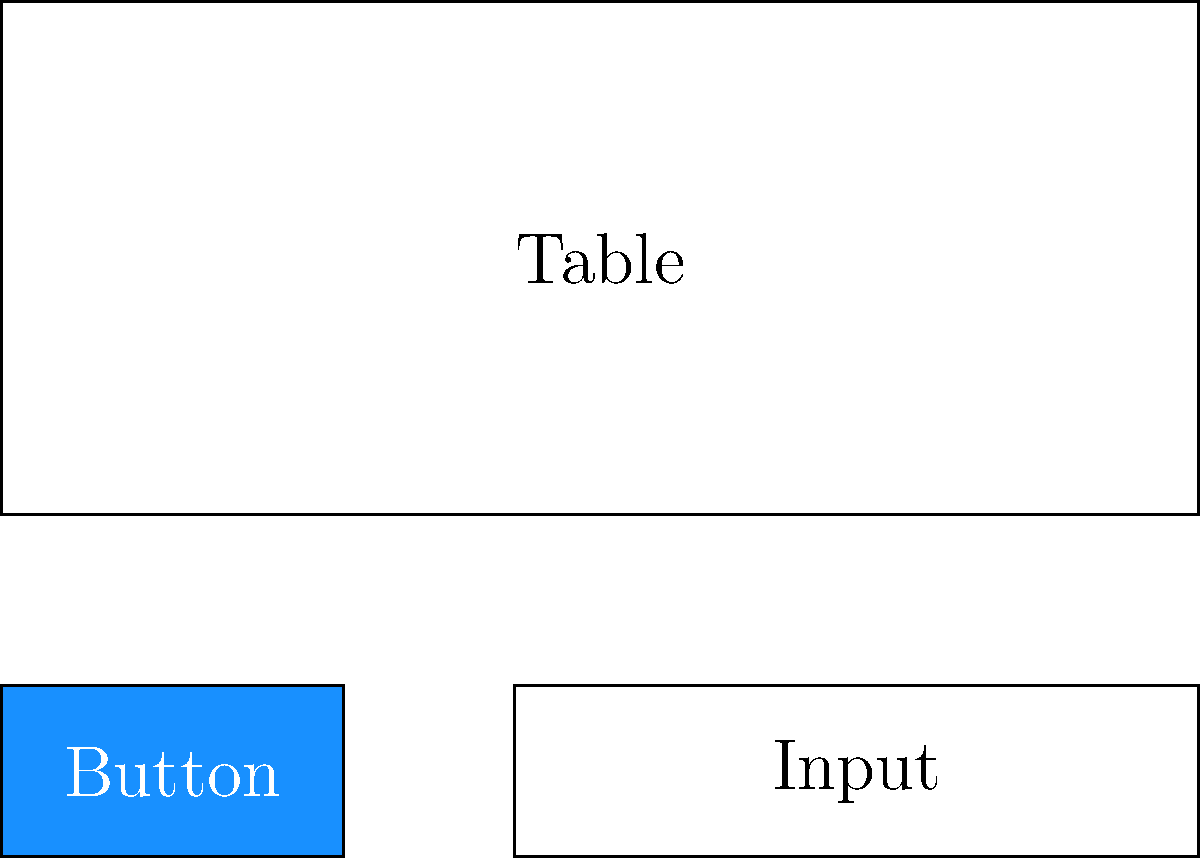Given the image above representing three common UI components, which machine learning approach would be most suitable for classifying these components based on their visual attributes, and what features would be most relevant for this classification task? To classify UI components based on their visual attributes using image recognition, we can follow these steps:

1. Approach Selection:
   - Convolutional Neural Networks (CNNs) are the most suitable for image classification tasks.
   - CNNs are effective at learning hierarchical features from images, making them ideal for UI component classification.

2. Relevant Features:
   a) Shape: 
      - Buttons are typically rectangular with rounded corners.
      - Input fields are usually longer rectangles.
      - Tables are larger rectangles with internal grid structures.
   
   b) Color:
      - Buttons often have distinct, solid colors (blue in this case).
      - Input fields and tables typically have lighter, neutral colors.
   
   c) Size and Aspect Ratio:
      - Buttons are usually smaller and have a different aspect ratio compared to input fields.
      - Tables are larger and have a distinct aspect ratio.
   
   d) Internal Structure:
      - Tables have grid lines or row/column structures.
      - Input fields may have placeholder text or icons.
      - Buttons typically contain centered text.

3. Data Preprocessing:
   - Normalize image sizes and color ranges.
   - Augment data with variations in size, color, and orientation to improve model robustness.

4. Model Architecture:
   - Use a CNN with multiple convolutional layers followed by pooling layers.
   - Include fully connected layers for final classification.
   - The output layer should have neurons corresponding to the number of UI component classes.

5. Training:
   - Use a large dataset of labeled UI components.
   - Employ techniques like transfer learning if the dataset is limited.

6. Evaluation:
   - Use metrics such as accuracy, precision, recall, and F1-score to assess model performance.
   - Implement cross-validation to ensure model generalization.

By focusing on these visual attributes and using a CNN, we can effectively classify UI components based on their appearance, which is particularly relevant for a front-end developer working with ReactJS and Ant Design components.
Answer: Convolutional Neural Networks (CNNs) with focus on shape, color, size, aspect ratio, and internal structure features. 